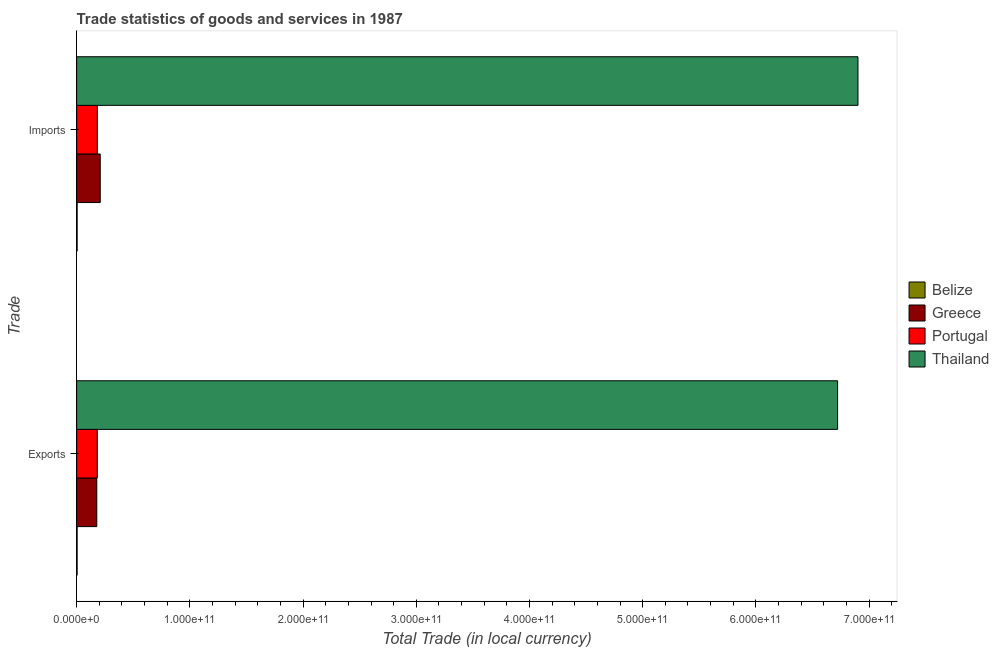How many different coloured bars are there?
Your answer should be compact. 4. Are the number of bars per tick equal to the number of legend labels?
Offer a terse response. Yes. Are the number of bars on each tick of the Y-axis equal?
Your answer should be compact. Yes. How many bars are there on the 1st tick from the top?
Keep it short and to the point. 4. How many bars are there on the 2nd tick from the bottom?
Give a very brief answer. 4. What is the label of the 2nd group of bars from the top?
Provide a short and direct response. Exports. What is the imports of goods and services in Portugal?
Ensure brevity in your answer.  1.82e+1. Across all countries, what is the maximum export of goods and services?
Offer a terse response. 6.72e+11. Across all countries, what is the minimum imports of goods and services?
Your answer should be compact. 4.29e+08. In which country was the imports of goods and services maximum?
Keep it short and to the point. Thailand. In which country was the imports of goods and services minimum?
Your answer should be very brief. Belize. What is the total imports of goods and services in the graph?
Make the answer very short. 7.30e+11. What is the difference between the export of goods and services in Portugal and that in Thailand?
Keep it short and to the point. -6.54e+11. What is the difference between the imports of goods and services in Greece and the export of goods and services in Portugal?
Offer a terse response. 2.62e+09. What is the average export of goods and services per country?
Ensure brevity in your answer.  1.77e+11. What is the difference between the imports of goods and services and export of goods and services in Portugal?
Give a very brief answer. 2.56e+07. In how many countries, is the imports of goods and services greater than 60000000000 LCU?
Give a very brief answer. 1. What is the ratio of the export of goods and services in Thailand to that in Greece?
Your answer should be very brief. 37.81. What does the 2nd bar from the top in Imports represents?
Provide a short and direct response. Portugal. What does the 1st bar from the bottom in Imports represents?
Your answer should be compact. Belize. How many bars are there?
Provide a short and direct response. 8. Are all the bars in the graph horizontal?
Your answer should be very brief. Yes. What is the difference between two consecutive major ticks on the X-axis?
Provide a short and direct response. 1.00e+11. Does the graph contain grids?
Offer a terse response. No. How many legend labels are there?
Your answer should be very brief. 4. What is the title of the graph?
Ensure brevity in your answer.  Trade statistics of goods and services in 1987. What is the label or title of the X-axis?
Make the answer very short. Total Trade (in local currency). What is the label or title of the Y-axis?
Your response must be concise. Trade. What is the Total Trade (in local currency) of Belize in Exports?
Make the answer very short. 4.14e+08. What is the Total Trade (in local currency) in Greece in Exports?
Give a very brief answer. 1.78e+1. What is the Total Trade (in local currency) in Portugal in Exports?
Give a very brief answer. 1.82e+1. What is the Total Trade (in local currency) of Thailand in Exports?
Provide a succinct answer. 6.72e+11. What is the Total Trade (in local currency) of Belize in Imports?
Make the answer very short. 4.29e+08. What is the Total Trade (in local currency) of Greece in Imports?
Provide a succinct answer. 2.08e+1. What is the Total Trade (in local currency) in Portugal in Imports?
Make the answer very short. 1.82e+1. What is the Total Trade (in local currency) of Thailand in Imports?
Provide a short and direct response. 6.90e+11. Across all Trade, what is the maximum Total Trade (in local currency) of Belize?
Provide a short and direct response. 4.29e+08. Across all Trade, what is the maximum Total Trade (in local currency) of Greece?
Your answer should be compact. 2.08e+1. Across all Trade, what is the maximum Total Trade (in local currency) of Portugal?
Provide a succinct answer. 1.82e+1. Across all Trade, what is the maximum Total Trade (in local currency) in Thailand?
Your answer should be very brief. 6.90e+11. Across all Trade, what is the minimum Total Trade (in local currency) of Belize?
Your answer should be very brief. 4.14e+08. Across all Trade, what is the minimum Total Trade (in local currency) in Greece?
Your answer should be very brief. 1.78e+1. Across all Trade, what is the minimum Total Trade (in local currency) in Portugal?
Offer a terse response. 1.82e+1. Across all Trade, what is the minimum Total Trade (in local currency) in Thailand?
Provide a succinct answer. 6.72e+11. What is the total Total Trade (in local currency) of Belize in the graph?
Provide a short and direct response. 8.43e+08. What is the total Total Trade (in local currency) of Greece in the graph?
Your response must be concise. 3.86e+1. What is the total Total Trade (in local currency) of Portugal in the graph?
Offer a very short reply. 3.64e+1. What is the total Total Trade (in local currency) of Thailand in the graph?
Make the answer very short. 1.36e+12. What is the difference between the Total Trade (in local currency) in Belize in Exports and that in Imports?
Give a very brief answer. -1.46e+07. What is the difference between the Total Trade (in local currency) of Greece in Exports and that in Imports?
Offer a terse response. -3.05e+09. What is the difference between the Total Trade (in local currency) of Portugal in Exports and that in Imports?
Your answer should be compact. -2.56e+07. What is the difference between the Total Trade (in local currency) in Thailand in Exports and that in Imports?
Your answer should be compact. -1.80e+1. What is the difference between the Total Trade (in local currency) in Belize in Exports and the Total Trade (in local currency) in Greece in Imports?
Make the answer very short. -2.04e+1. What is the difference between the Total Trade (in local currency) of Belize in Exports and the Total Trade (in local currency) of Portugal in Imports?
Make the answer very short. -1.78e+1. What is the difference between the Total Trade (in local currency) in Belize in Exports and the Total Trade (in local currency) in Thailand in Imports?
Offer a terse response. -6.90e+11. What is the difference between the Total Trade (in local currency) in Greece in Exports and the Total Trade (in local currency) in Portugal in Imports?
Your answer should be very brief. -4.55e+08. What is the difference between the Total Trade (in local currency) in Greece in Exports and the Total Trade (in local currency) in Thailand in Imports?
Your answer should be very brief. -6.72e+11. What is the difference between the Total Trade (in local currency) in Portugal in Exports and the Total Trade (in local currency) in Thailand in Imports?
Offer a very short reply. -6.72e+11. What is the average Total Trade (in local currency) of Belize per Trade?
Ensure brevity in your answer.  4.22e+08. What is the average Total Trade (in local currency) in Greece per Trade?
Keep it short and to the point. 1.93e+1. What is the average Total Trade (in local currency) of Portugal per Trade?
Offer a terse response. 1.82e+1. What is the average Total Trade (in local currency) in Thailand per Trade?
Give a very brief answer. 6.81e+11. What is the difference between the Total Trade (in local currency) in Belize and Total Trade (in local currency) in Greece in Exports?
Your response must be concise. -1.74e+1. What is the difference between the Total Trade (in local currency) of Belize and Total Trade (in local currency) of Portugal in Exports?
Provide a succinct answer. -1.78e+1. What is the difference between the Total Trade (in local currency) of Belize and Total Trade (in local currency) of Thailand in Exports?
Your answer should be compact. -6.72e+11. What is the difference between the Total Trade (in local currency) of Greece and Total Trade (in local currency) of Portugal in Exports?
Your answer should be compact. -4.29e+08. What is the difference between the Total Trade (in local currency) of Greece and Total Trade (in local currency) of Thailand in Exports?
Provide a succinct answer. -6.54e+11. What is the difference between the Total Trade (in local currency) of Portugal and Total Trade (in local currency) of Thailand in Exports?
Offer a terse response. -6.54e+11. What is the difference between the Total Trade (in local currency) of Belize and Total Trade (in local currency) of Greece in Imports?
Your response must be concise. -2.04e+1. What is the difference between the Total Trade (in local currency) in Belize and Total Trade (in local currency) in Portugal in Imports?
Give a very brief answer. -1.78e+1. What is the difference between the Total Trade (in local currency) of Belize and Total Trade (in local currency) of Thailand in Imports?
Your answer should be very brief. -6.90e+11. What is the difference between the Total Trade (in local currency) in Greece and Total Trade (in local currency) in Portugal in Imports?
Provide a short and direct response. 2.59e+09. What is the difference between the Total Trade (in local currency) of Greece and Total Trade (in local currency) of Thailand in Imports?
Keep it short and to the point. -6.69e+11. What is the difference between the Total Trade (in local currency) of Portugal and Total Trade (in local currency) of Thailand in Imports?
Give a very brief answer. -6.72e+11. What is the ratio of the Total Trade (in local currency) in Belize in Exports to that in Imports?
Give a very brief answer. 0.97. What is the ratio of the Total Trade (in local currency) in Greece in Exports to that in Imports?
Offer a very short reply. 0.85. What is the ratio of the Total Trade (in local currency) in Portugal in Exports to that in Imports?
Offer a terse response. 1. What is the ratio of the Total Trade (in local currency) of Thailand in Exports to that in Imports?
Give a very brief answer. 0.97. What is the difference between the highest and the second highest Total Trade (in local currency) of Belize?
Your answer should be very brief. 1.46e+07. What is the difference between the highest and the second highest Total Trade (in local currency) of Greece?
Keep it short and to the point. 3.05e+09. What is the difference between the highest and the second highest Total Trade (in local currency) in Portugal?
Keep it short and to the point. 2.56e+07. What is the difference between the highest and the second highest Total Trade (in local currency) of Thailand?
Your answer should be very brief. 1.80e+1. What is the difference between the highest and the lowest Total Trade (in local currency) of Belize?
Provide a succinct answer. 1.46e+07. What is the difference between the highest and the lowest Total Trade (in local currency) of Greece?
Provide a succinct answer. 3.05e+09. What is the difference between the highest and the lowest Total Trade (in local currency) of Portugal?
Keep it short and to the point. 2.56e+07. What is the difference between the highest and the lowest Total Trade (in local currency) in Thailand?
Provide a succinct answer. 1.80e+1. 